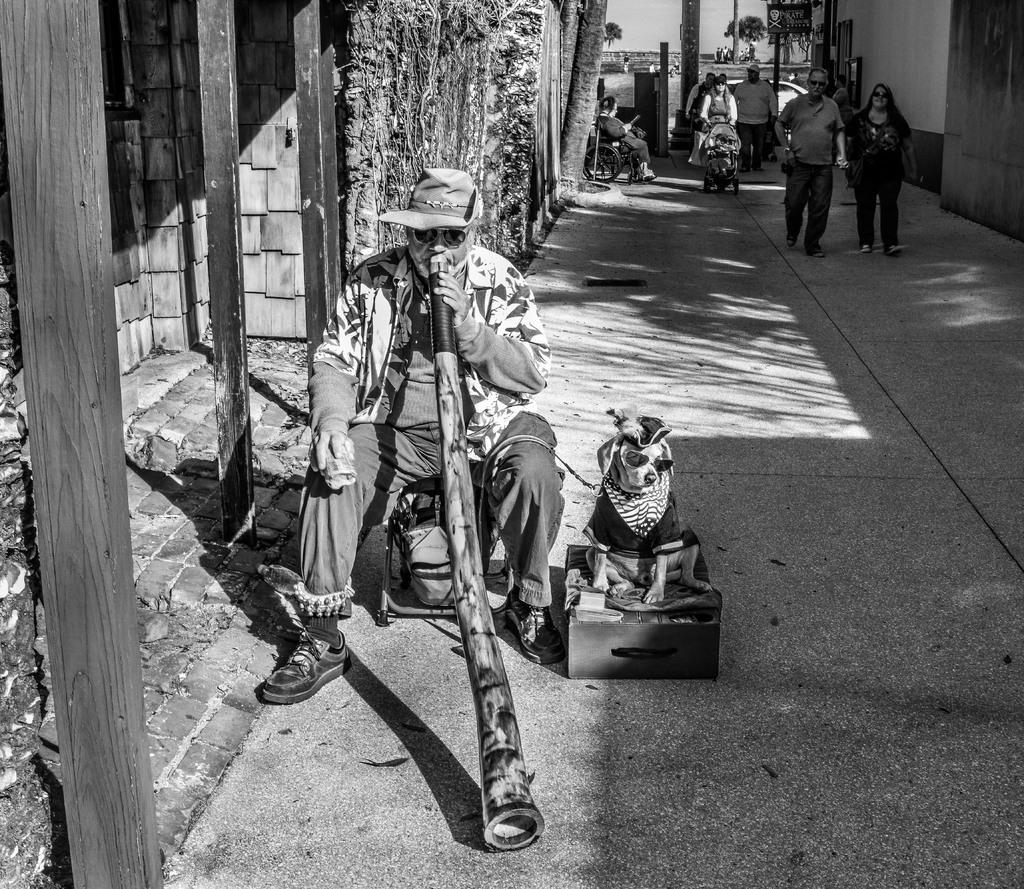In one or two sentences, can you explain what this image depicts? In this image we can see a person wearing cap and goggles. He is sitting on something and he is playing a musical instrument. Near to him there is a dog sitting on a box. On the left side there is a building with pillars. In the back there are few people. There is a person on a wheelchair. In the background there are trees. 